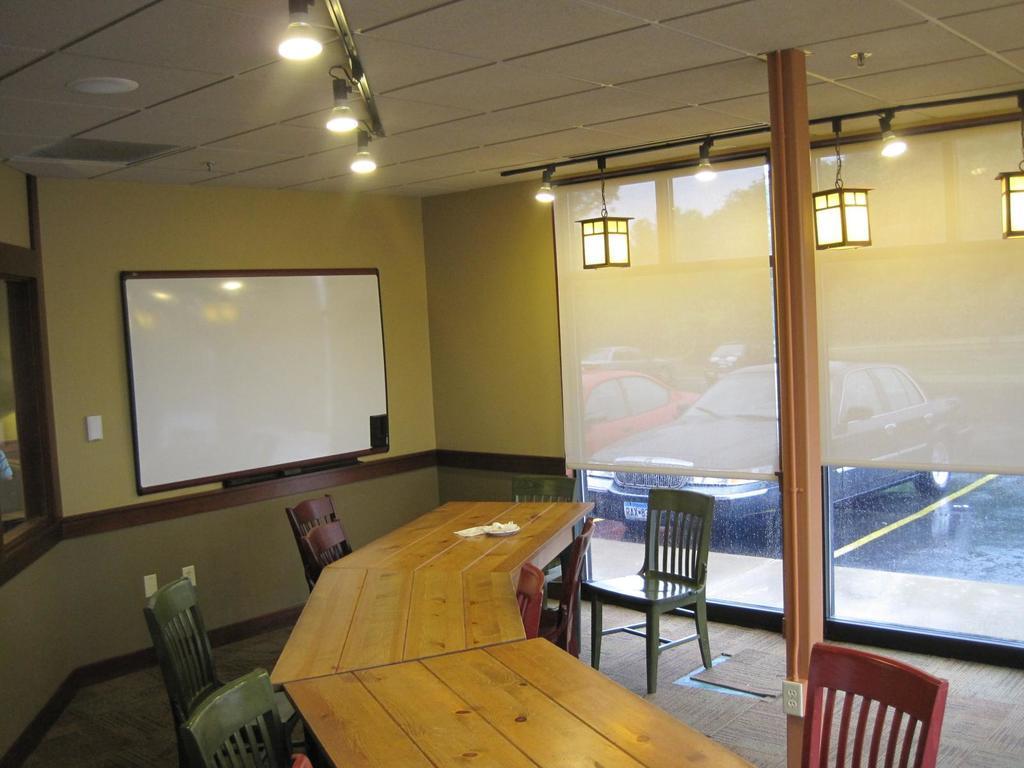Describe this image in one or two sentences. In this image we can see electric lights, display screen, chairs, desks, floor, carpet, curtains, car and road. 